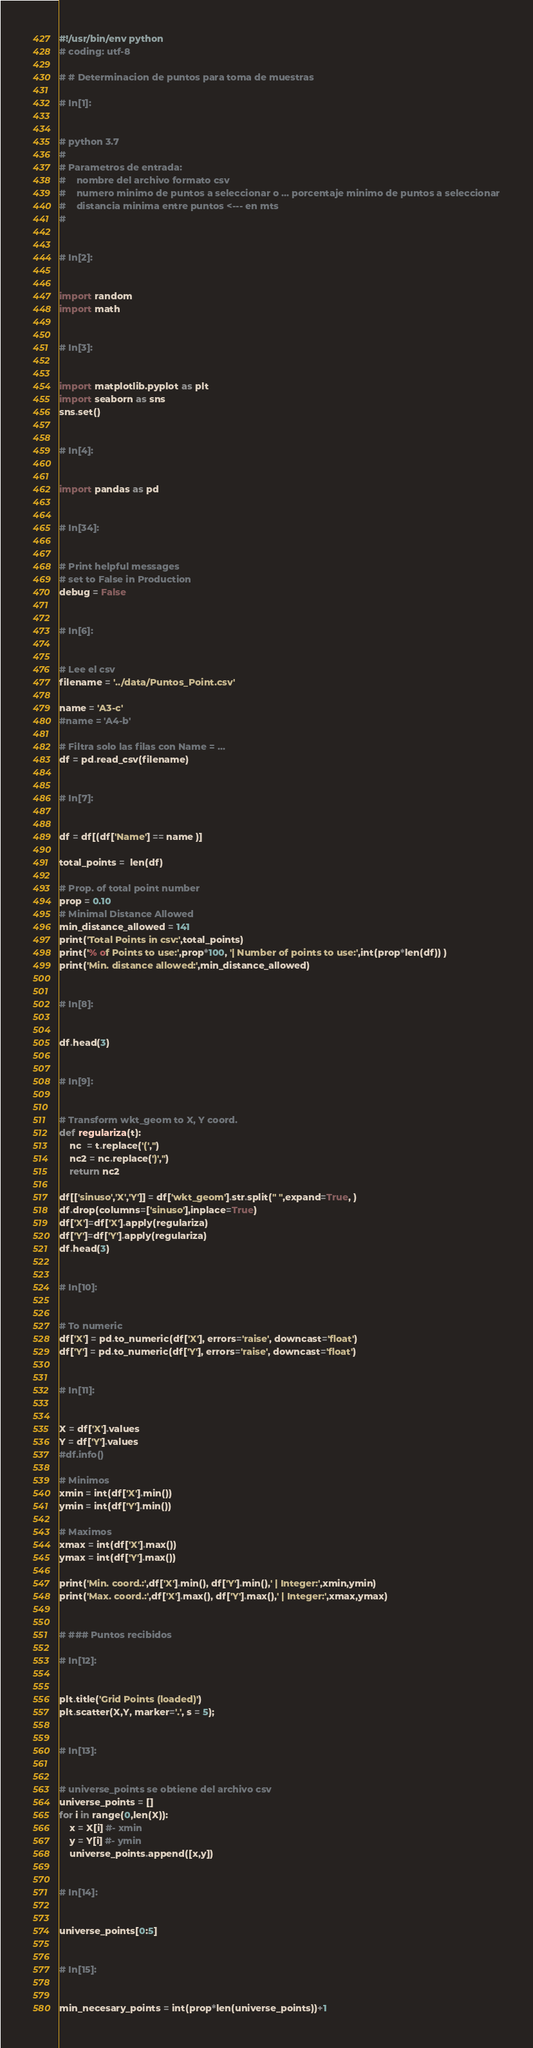Convert code to text. <code><loc_0><loc_0><loc_500><loc_500><_Python_>#!/usr/bin/env python
# coding: utf-8

# # Determinacion de puntos para toma de muestras

# In[1]:


# python 3.7
#
# Parametros de entrada:
#    nombre del archivo formato csv
#    numero minimo de puntos a seleccionar o ... porcentaje minimo de puntos a seleccionar
#    distancia minima entre puntos <--- en mts
#


# In[2]:


import random
import math


# In[3]:


import matplotlib.pyplot as plt
import seaborn as sns
sns.set()


# In[4]:


import pandas as pd


# In[34]:


# Print helpful messages
# set to False in Production
debug = False


# In[6]:


# Lee el csv
filename = '../data/Puntos_Point.csv'

name = 'A3-c'
#name = 'A4-b'

# Filtra solo las filas con Name = ...
df = pd.read_csv(filename)


# In[7]:


df = df[(df['Name'] == name )]

total_points =  len(df)

# Prop. of total point number
prop = 0.10
# Minimal Distance Allowed
min_distance_allowed = 141
print('Total Points in csv:',total_points)
print('% of Points to use:',prop*100, '| Number of points to use:',int(prop*len(df)) )
print('Min. distance allowed:',min_distance_allowed)


# In[8]:


df.head(3)


# In[9]:


# Transform wkt_geom to X, Y coord.
def regulariza(t):
    nc  = t.replace('(','')
    nc2 = nc.replace(')','')
    return nc2 

df[['sinuso','X','Y']] = df['wkt_geom'].str.split(" ",expand=True, )
df.drop(columns=['sinuso'],inplace=True)
df['X']=df['X'].apply(regulariza)
df['Y']=df['Y'].apply(regulariza)
df.head(3)


# In[10]:


# To numeric
df['X'] = pd.to_numeric(df['X'], errors='raise', downcast='float')
df['Y'] = pd.to_numeric(df['Y'], errors='raise', downcast='float')


# In[11]:


X = df['X'].values
Y = df['Y'].values
#df.info()

# Minimos
xmin = int(df['X'].min())
ymin = int(df['Y'].min())

# Maximos
xmax = int(df['X'].max())
ymax = int(df['Y'].max())

print('Min. coord.:',df['X'].min(), df['Y'].min(),' | Integer:',xmin,ymin)
print('Max. coord.:',df['X'].max(), df['Y'].max(),' | Integer:',xmax,ymax)


# ### Puntos recibidos

# In[12]:


plt.title('Grid Points (loaded)')
plt.scatter(X,Y, marker='.', s = 5);


# In[13]:


# universe_points se obtiene del archivo csv
universe_points = []
for i in range(0,len(X)):
    x = X[i] #- xmin
    y = Y[i] #- ymin
    universe_points.append([x,y])


# In[14]:


universe_points[0:5]


# In[15]:


min_necesary_points = int(prop*len(universe_points))+1</code> 